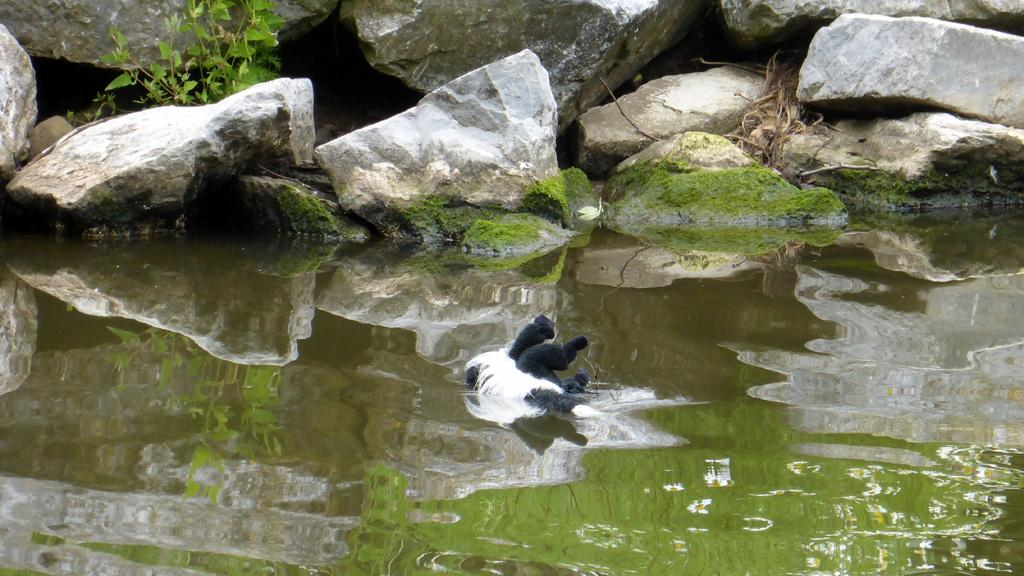What type of animal is in the image? The type of animal cannot be determined from the provided facts. What is the primary element in the image? There is water in the image. What can be seen in the background of the image? There is a plant and rocks in the background of the image. What news headline is being read by the animal in the image? There is no animal reading a news headline in the image, as the type of animal cannot be determined. Is the animal taking a bath in the water in the image? There is no indication that the animal is taking a bath in the water in the image, as the type of animal cannot be determined. 